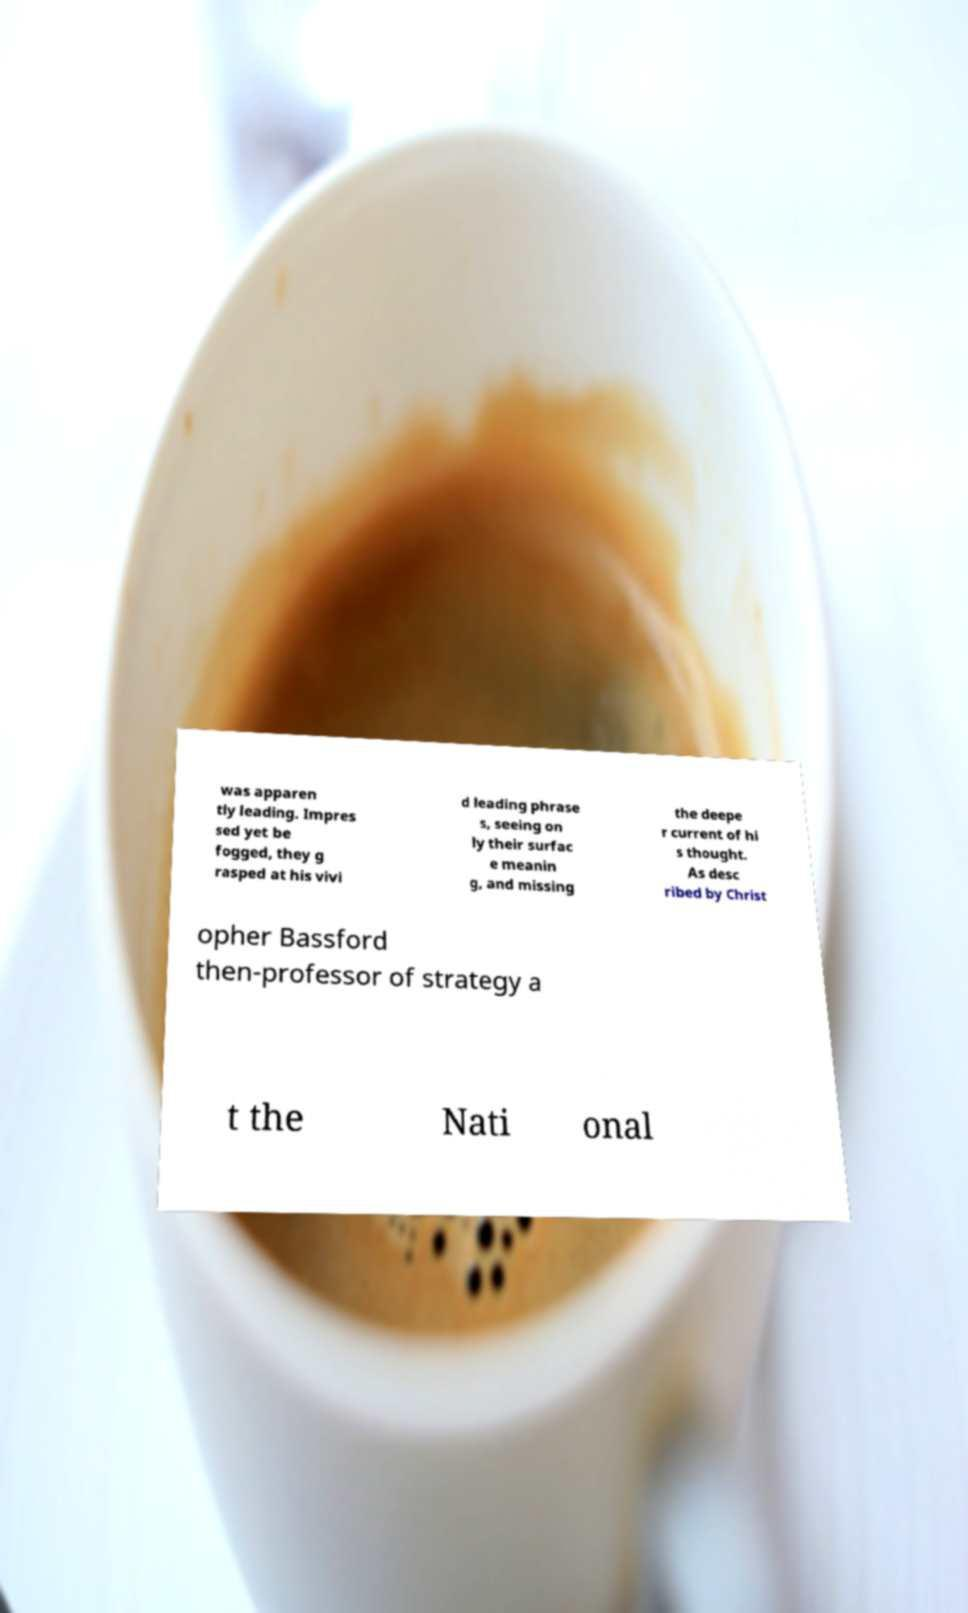Can you read and provide the text displayed in the image?This photo seems to have some interesting text. Can you extract and type it out for me? was apparen tly leading. Impres sed yet be fogged, they g rasped at his vivi d leading phrase s, seeing on ly their surfac e meanin g, and missing the deepe r current of hi s thought. As desc ribed by Christ opher Bassford then-professor of strategy a t the Nati onal 